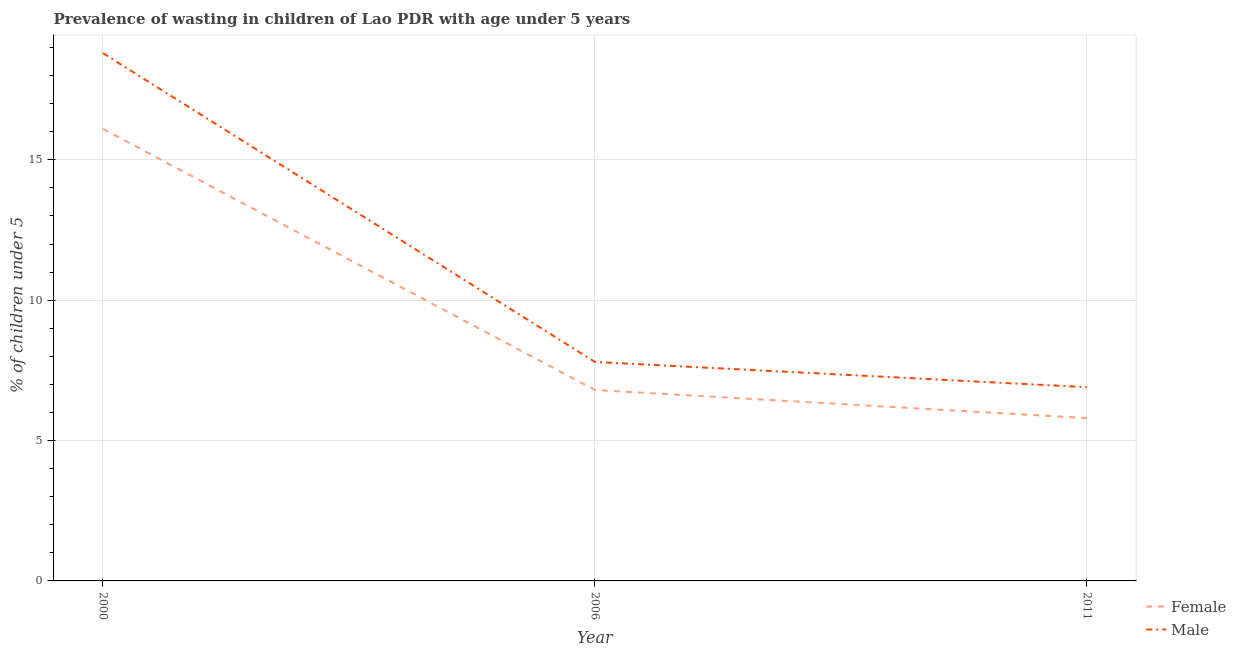How many different coloured lines are there?
Your response must be concise. 2. Does the line corresponding to percentage of undernourished male children intersect with the line corresponding to percentage of undernourished female children?
Give a very brief answer. No. Is the number of lines equal to the number of legend labels?
Offer a very short reply. Yes. What is the percentage of undernourished female children in 2006?
Make the answer very short. 6.8. Across all years, what is the maximum percentage of undernourished female children?
Your response must be concise. 16.1. Across all years, what is the minimum percentage of undernourished female children?
Make the answer very short. 5.8. What is the total percentage of undernourished female children in the graph?
Ensure brevity in your answer.  28.7. What is the difference between the percentage of undernourished female children in 2000 and that in 2011?
Offer a terse response. 10.3. What is the difference between the percentage of undernourished male children in 2011 and the percentage of undernourished female children in 2006?
Provide a succinct answer. 0.1. What is the average percentage of undernourished male children per year?
Your answer should be compact. 11.17. In the year 2000, what is the difference between the percentage of undernourished male children and percentage of undernourished female children?
Offer a terse response. 2.7. What is the ratio of the percentage of undernourished male children in 2000 to that in 2006?
Offer a very short reply. 2.41. What is the difference between the highest and the second highest percentage of undernourished female children?
Your response must be concise. 9.3. What is the difference between the highest and the lowest percentage of undernourished male children?
Keep it short and to the point. 11.9. Is the percentage of undernourished male children strictly greater than the percentage of undernourished female children over the years?
Provide a short and direct response. Yes. Is the percentage of undernourished female children strictly less than the percentage of undernourished male children over the years?
Keep it short and to the point. Yes. How many lines are there?
Your answer should be compact. 2. How many years are there in the graph?
Offer a very short reply. 3. Does the graph contain any zero values?
Your answer should be compact. No. Does the graph contain grids?
Your answer should be very brief. Yes. What is the title of the graph?
Your answer should be very brief. Prevalence of wasting in children of Lao PDR with age under 5 years. Does "Quasi money growth" appear as one of the legend labels in the graph?
Offer a very short reply. No. What is the label or title of the X-axis?
Provide a succinct answer. Year. What is the label or title of the Y-axis?
Keep it short and to the point.  % of children under 5. What is the  % of children under 5 in Female in 2000?
Provide a short and direct response. 16.1. What is the  % of children under 5 of Male in 2000?
Keep it short and to the point. 18.8. What is the  % of children under 5 of Female in 2006?
Give a very brief answer. 6.8. What is the  % of children under 5 of Male in 2006?
Your response must be concise. 7.8. What is the  % of children under 5 of Female in 2011?
Offer a terse response. 5.8. What is the  % of children under 5 in Male in 2011?
Provide a succinct answer. 6.9. Across all years, what is the maximum  % of children under 5 in Female?
Give a very brief answer. 16.1. Across all years, what is the maximum  % of children under 5 of Male?
Your answer should be compact. 18.8. Across all years, what is the minimum  % of children under 5 of Female?
Give a very brief answer. 5.8. Across all years, what is the minimum  % of children under 5 in Male?
Your answer should be very brief. 6.9. What is the total  % of children under 5 in Female in the graph?
Make the answer very short. 28.7. What is the total  % of children under 5 in Male in the graph?
Provide a short and direct response. 33.5. What is the difference between the  % of children under 5 in Female in 2006 and that in 2011?
Give a very brief answer. 1. What is the difference between the  % of children under 5 in Female in 2006 and the  % of children under 5 in Male in 2011?
Make the answer very short. -0.1. What is the average  % of children under 5 in Female per year?
Your response must be concise. 9.57. What is the average  % of children under 5 of Male per year?
Offer a terse response. 11.17. In the year 2006, what is the difference between the  % of children under 5 of Female and  % of children under 5 of Male?
Give a very brief answer. -1. What is the ratio of the  % of children under 5 of Female in 2000 to that in 2006?
Your response must be concise. 2.37. What is the ratio of the  % of children under 5 of Male in 2000 to that in 2006?
Provide a succinct answer. 2.41. What is the ratio of the  % of children under 5 of Female in 2000 to that in 2011?
Offer a very short reply. 2.78. What is the ratio of the  % of children under 5 of Male in 2000 to that in 2011?
Ensure brevity in your answer.  2.72. What is the ratio of the  % of children under 5 in Female in 2006 to that in 2011?
Make the answer very short. 1.17. What is the ratio of the  % of children under 5 of Male in 2006 to that in 2011?
Keep it short and to the point. 1.13. What is the difference between the highest and the second highest  % of children under 5 in Male?
Provide a short and direct response. 11. What is the difference between the highest and the lowest  % of children under 5 in Male?
Offer a very short reply. 11.9. 